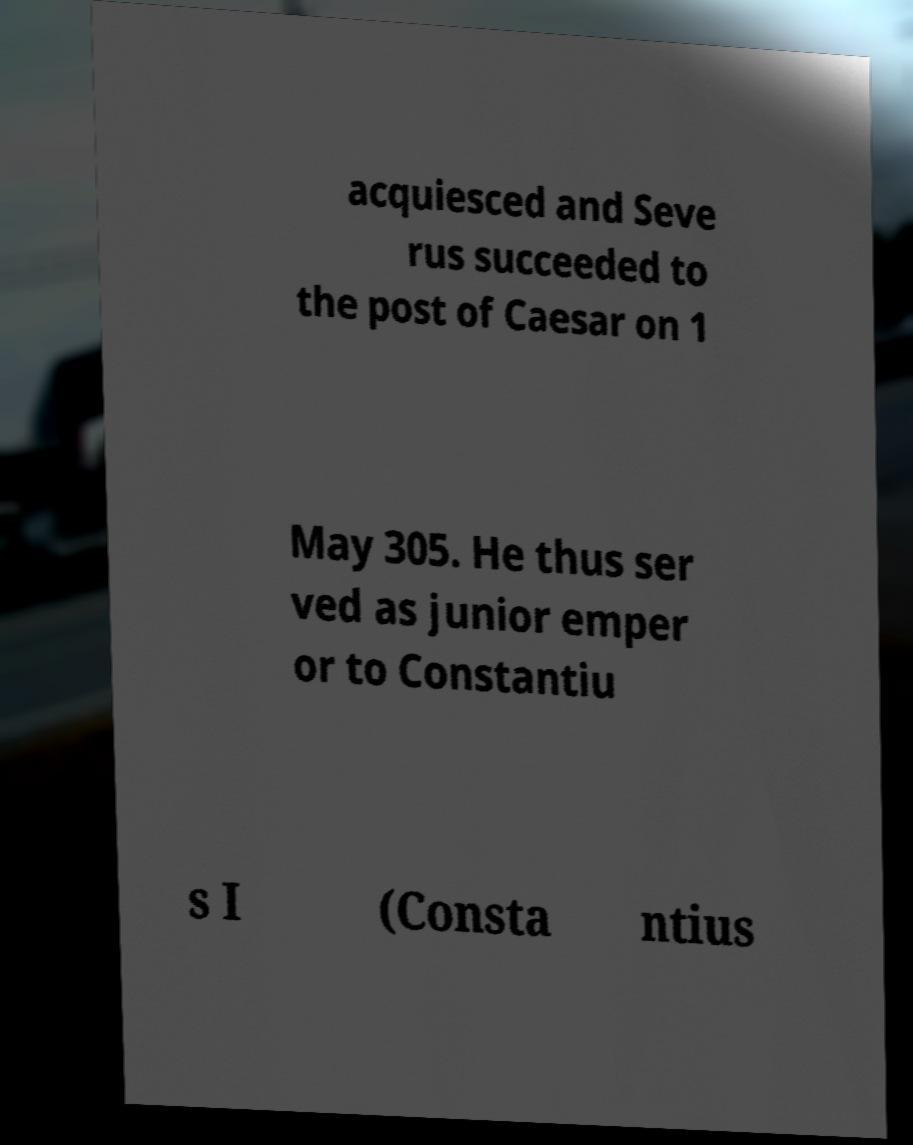What messages or text are displayed in this image? I need them in a readable, typed format. acquiesced and Seve rus succeeded to the post of Caesar on 1 May 305. He thus ser ved as junior emper or to Constantiu s I (Consta ntius 